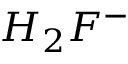<formula> <loc_0><loc_0><loc_500><loc_500>H _ { 2 } F ^ { - }</formula> 